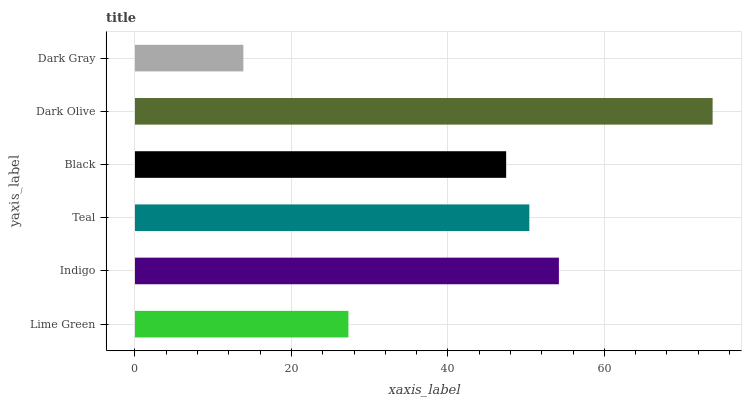Is Dark Gray the minimum?
Answer yes or no. Yes. Is Dark Olive the maximum?
Answer yes or no. Yes. Is Indigo the minimum?
Answer yes or no. No. Is Indigo the maximum?
Answer yes or no. No. Is Indigo greater than Lime Green?
Answer yes or no. Yes. Is Lime Green less than Indigo?
Answer yes or no. Yes. Is Lime Green greater than Indigo?
Answer yes or no. No. Is Indigo less than Lime Green?
Answer yes or no. No. Is Teal the high median?
Answer yes or no. Yes. Is Black the low median?
Answer yes or no. Yes. Is Dark Olive the high median?
Answer yes or no. No. Is Indigo the low median?
Answer yes or no. No. 